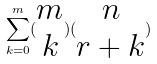Convert formula to latex. <formula><loc_0><loc_0><loc_500><loc_500>\sum _ { k = 0 } ^ { m } ( \begin{matrix} m \\ k \end{matrix} ) ( \begin{matrix} n \\ r + k \end{matrix} )</formula> 